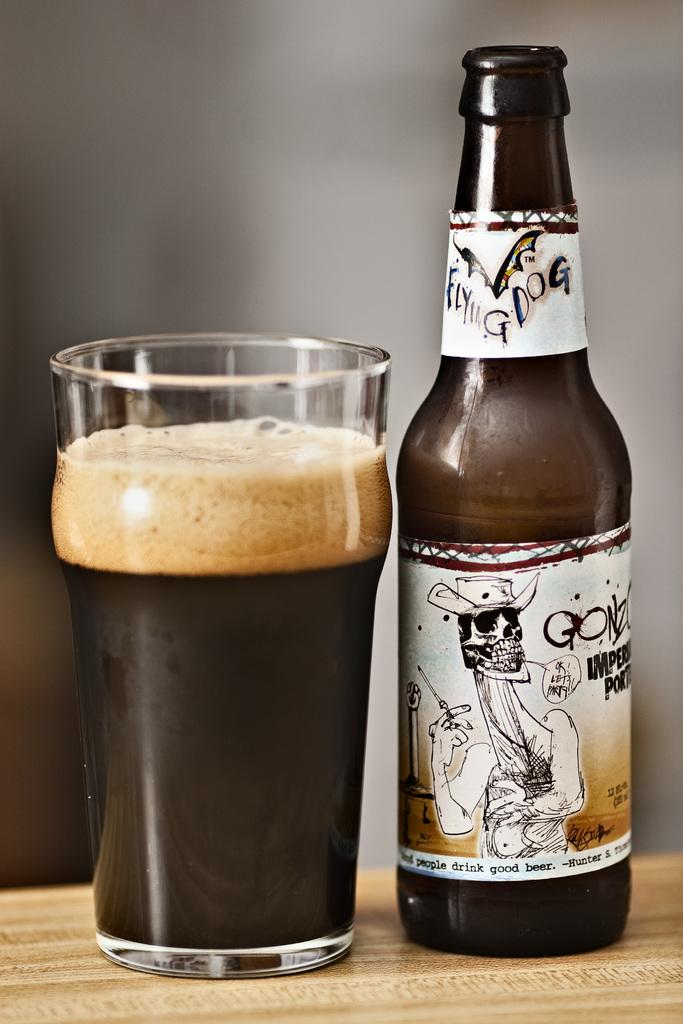<image>
Summarize the visual content of the image. A bottle of Flying Dog beer next to a glass of beer with a thick head. 